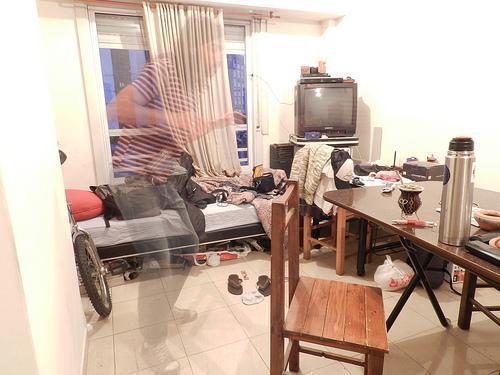How many televisions are there?
Give a very brief answer. 1. How many people are in the photo?
Give a very brief answer. 1. 